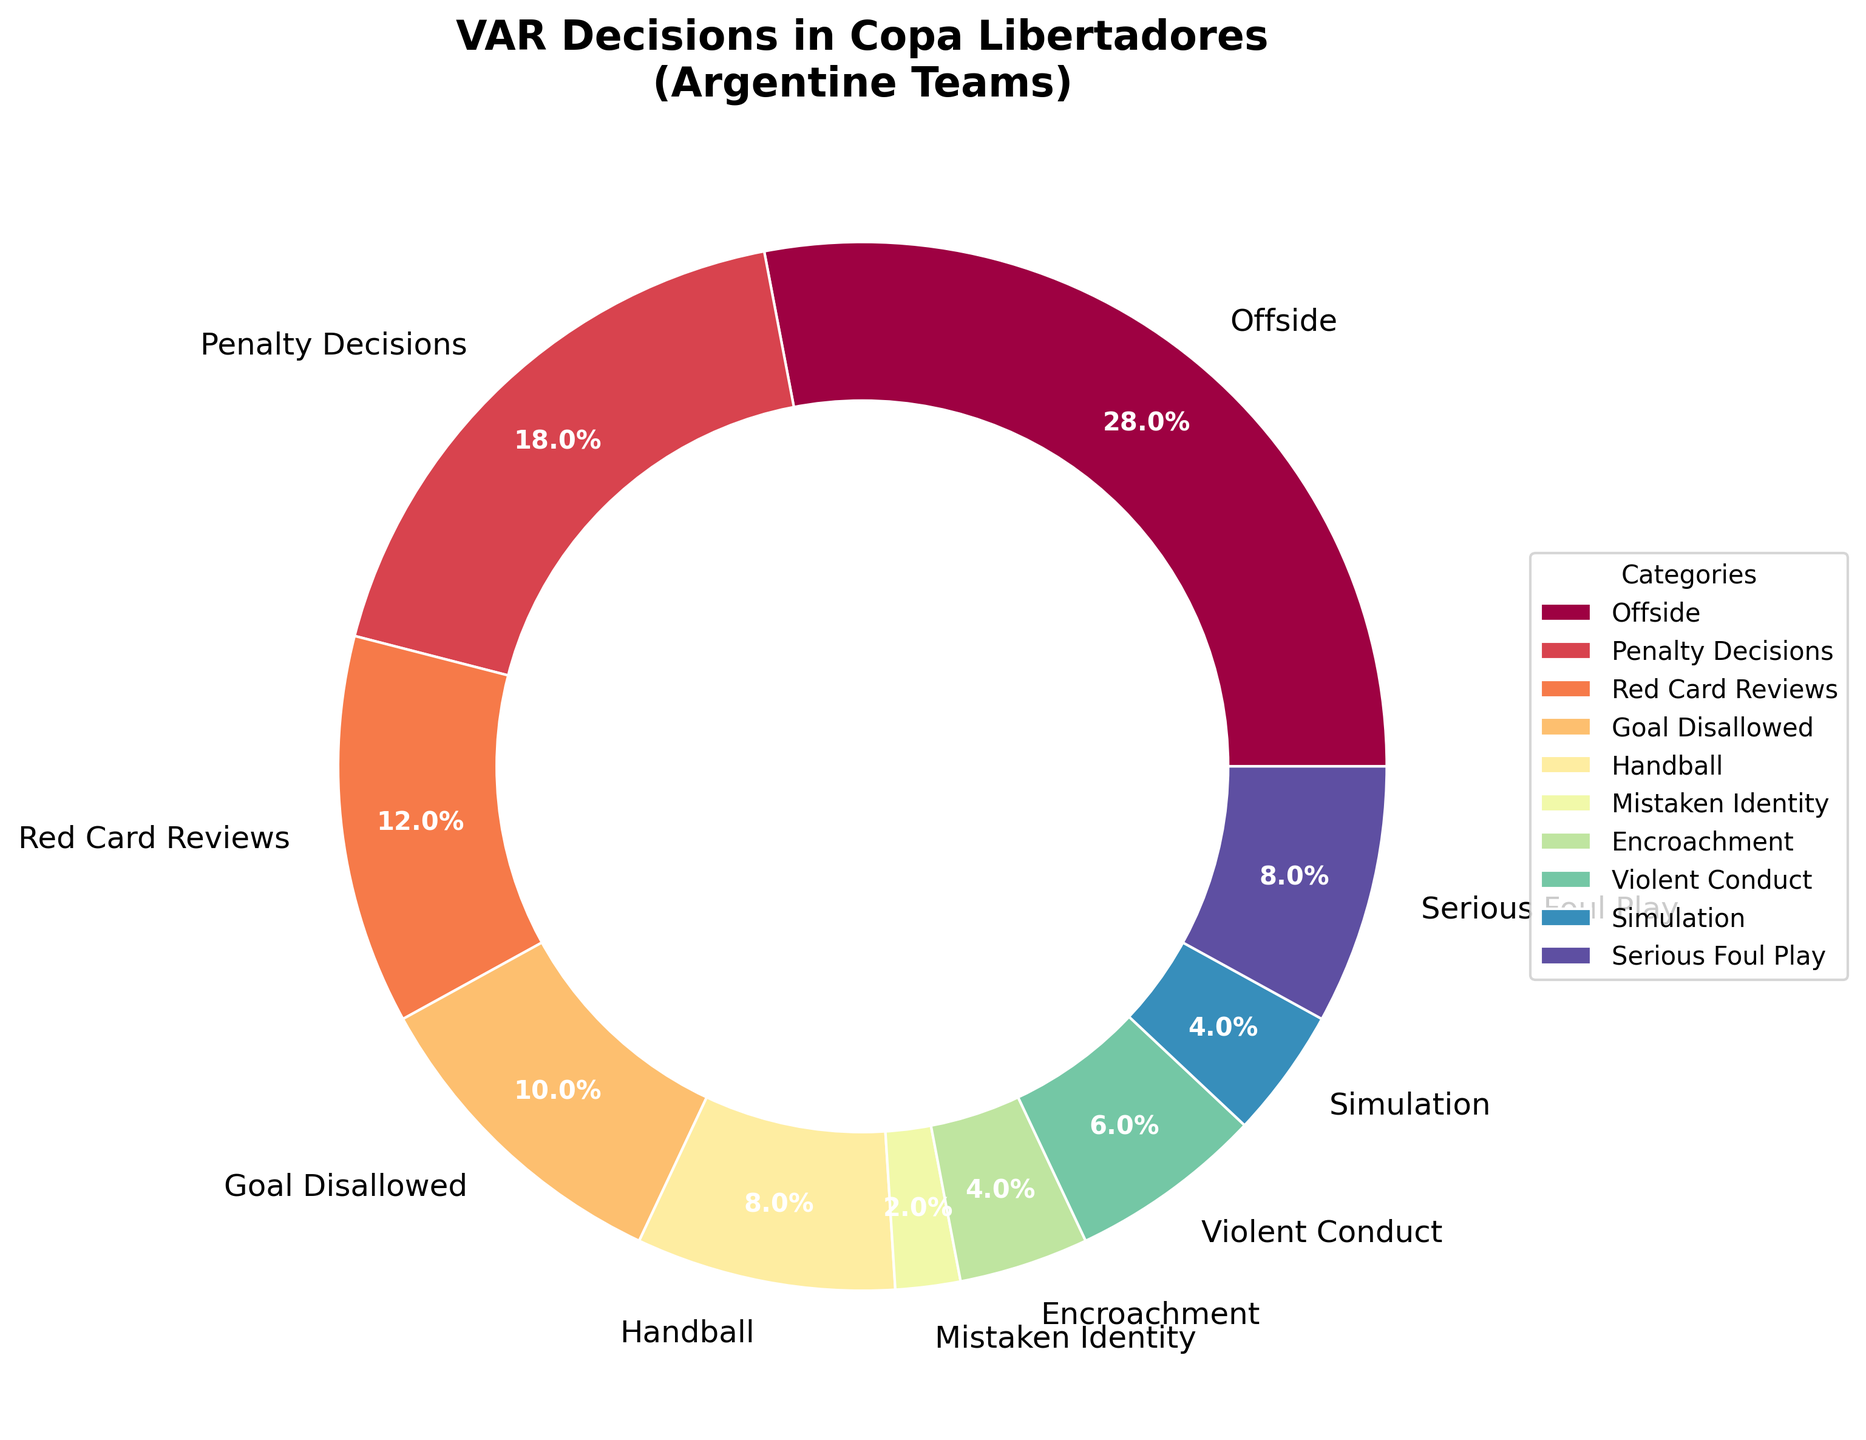Which category has the highest number of overturned decisions by VAR? The category 'Offside' has the largest slice in the pie chart, indicating it has the highest number of overturned decisions by VAR.
Answer: Offside How many more overturned decisions were there for Offside compared to Handball? Offside accounts for 14 overturned decisions, while Handball accounts for 4. Thus, 14 - 4 = 10 more decisions were overturned for Offside compared to Handball.
Answer: 10 What percentage of overturned decisions are related to goal disallowed scenarios? The 'Goal Disallowed' category represents 5 decisions. In percentage terms, this can be calculated as (5 / 50) * 100%, where 50 is the total number of decisions. Hence, (5 / 50) * 100% = 10%.
Answer: 10% Which category has the smallest number of overturned decisions by VAR? The 'Mistaken Identity' category has the smallest slice in the pie chart, indicating it has the least number of overturned decisions by VAR.
Answer: Mistaken Identity Are there more overturned decisions for Simulation or Encroachment? Both Simulation and Encroachment categories have equal slices of 2 decisions each in the pie chart.
Answer: They are equal What is the combined percentage of overturned decisions for Penalty Decisions and Red Card Reviews? Penalty Decisions and Red Card Reviews account for 9 and 6 decisions respectively. Their total percentage is calculated as [(9 + 6) / 50] * 100% = 30%.
Answer: 30% Which two categories have an equal number of overturned decisions, and what is that number? 'Encroachment' and 'Simulation' categories both have 2 overturned decisions each as represented by equal-sized slices in the pie chart.
Answer: Encroachment and Simulation with 2 decisions each What portion of overturned decisions does the category Serious Foul Play account for? Serious Foul Play accounts for 4 overturned decisions. Thus, its portion is calculated as (4 / 50) * 100%, which equals 8%.
Answer: 8% Is the number of overturned decisions for Violent Conduct greater than for Goal Disallowed? Violent Conduct accounts for 3 decisions, whereas Goal Disallowed accounts for 5. Therefore, the number of overturned decisions for Violent Conduct is less than for Goal Disallowed.
Answer: Less than 